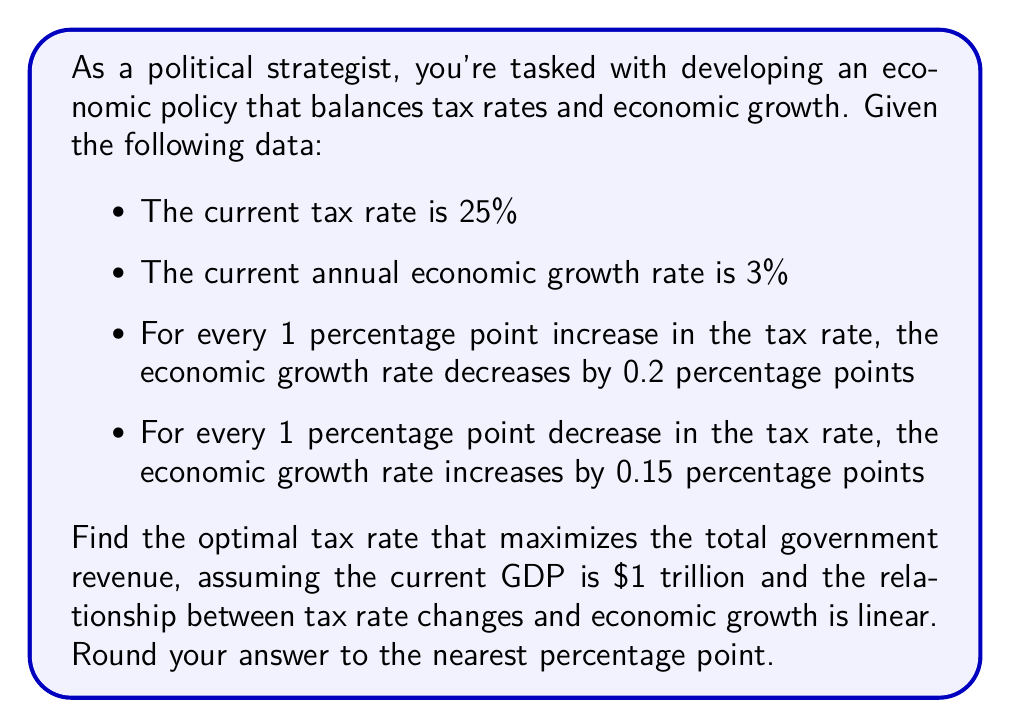Help me with this question. To solve this problem, we need to find the tax rate that maximizes government revenue. Let's approach this step-by-step:

1) First, let's define our variables:
   $t$ = tax rate
   $g$ = economic growth rate
   $R$ = government revenue

2) We can express the economic growth rate as a function of the tax rate:
   $g = 3 - 0.2(t - 25)$ for $t > 25$
   $g = 3 + 0.15(25 - t)$ for $t < 25$

3) The government revenue can be expressed as:
   $R = t \cdot GDP \cdot (1 + g)$

4) Substituting the GDP and the growth rate function:
   For $t > 25$: $R = t \cdot 1,000,000,000,000 \cdot (1 + (3 - 0.2(t - 25))/100)$
   For $t < 25$: $R = t \cdot 1,000,000,000,000 \cdot (1 + (3 + 0.15(25 - t))/100)$

5) Simplifying:
   For $t > 25$: $R = 10^{12}t(1.03 - 0.002t + 0.05)$
   For $t < 25$: $R = 10^{12}t(1.03 + 0.0375 - 0.0015t)$

6) To find the maximum, we need to differentiate R with respect to t and set it to zero:
   For $t > 25$: $\frac{dR}{dt} = 10^{12}(1.08 - 0.004t) = 0$
                 Solving this: $t = 27$

   For $t < 25$: $\frac{dR}{dt} = 10^{12}(1.0675 - 0.003t) = 0$
                 Solving this: $t = 35.58$ (which is outside our range)

7) We also need to check the endpoints at $t = 25$:
   $R(25) = 25 \cdot 10^{12} \cdot 1.03 = 25.75 \cdot 10^{12}$
   $R(27) = 27 \cdot 10^{12} \cdot (1.03 - 0.002 \cdot 27 + 0.05) = 25.812 \cdot 10^{12}$

8) The maximum revenue occurs at $t = 27$, which rounded to the nearest percentage point is 27%.
Answer: 27% 